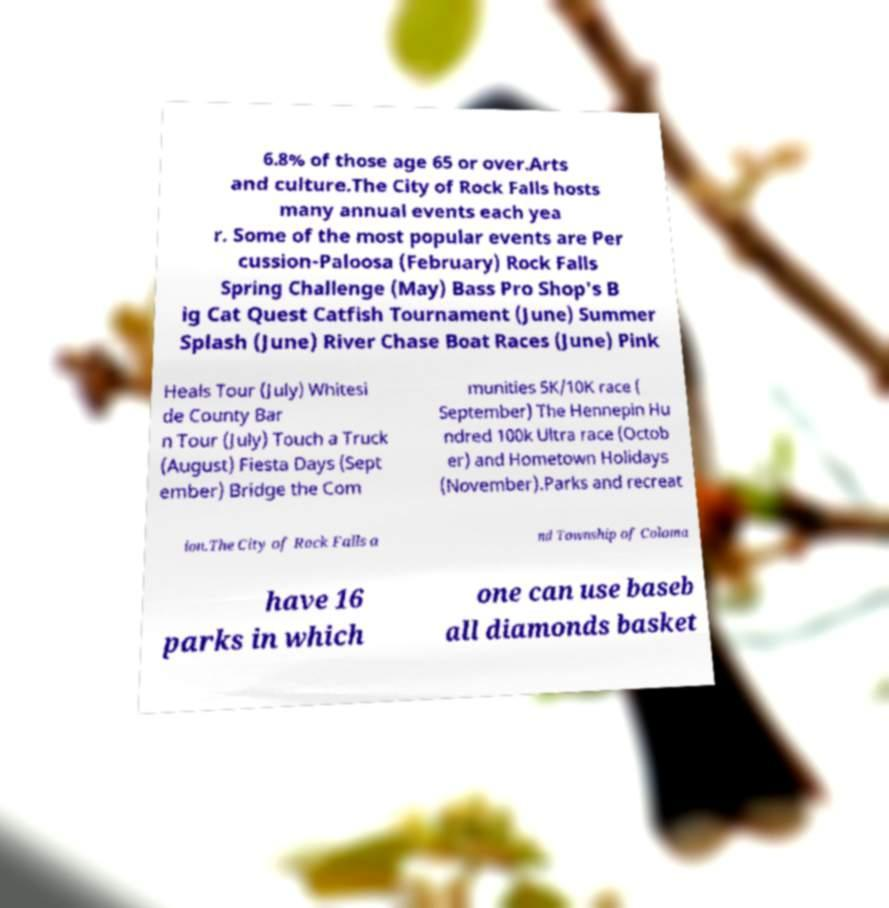Can you read and provide the text displayed in the image?This photo seems to have some interesting text. Can you extract and type it out for me? 6.8% of those age 65 or over.Arts and culture.The City of Rock Falls hosts many annual events each yea r. Some of the most popular events are Per cussion-Paloosa (February) Rock Falls Spring Challenge (May) Bass Pro Shop's B ig Cat Quest Catfish Tournament (June) Summer Splash (June) River Chase Boat Races (June) Pink Heals Tour (July) Whitesi de County Bar n Tour (July) Touch a Truck (August) Fiesta Days (Sept ember) Bridge the Com munities 5K/10K race ( September) The Hennepin Hu ndred 100k Ultra race (Octob er) and Hometown Holidays (November).Parks and recreat ion.The City of Rock Falls a nd Township of Coloma have 16 parks in which one can use baseb all diamonds basket 